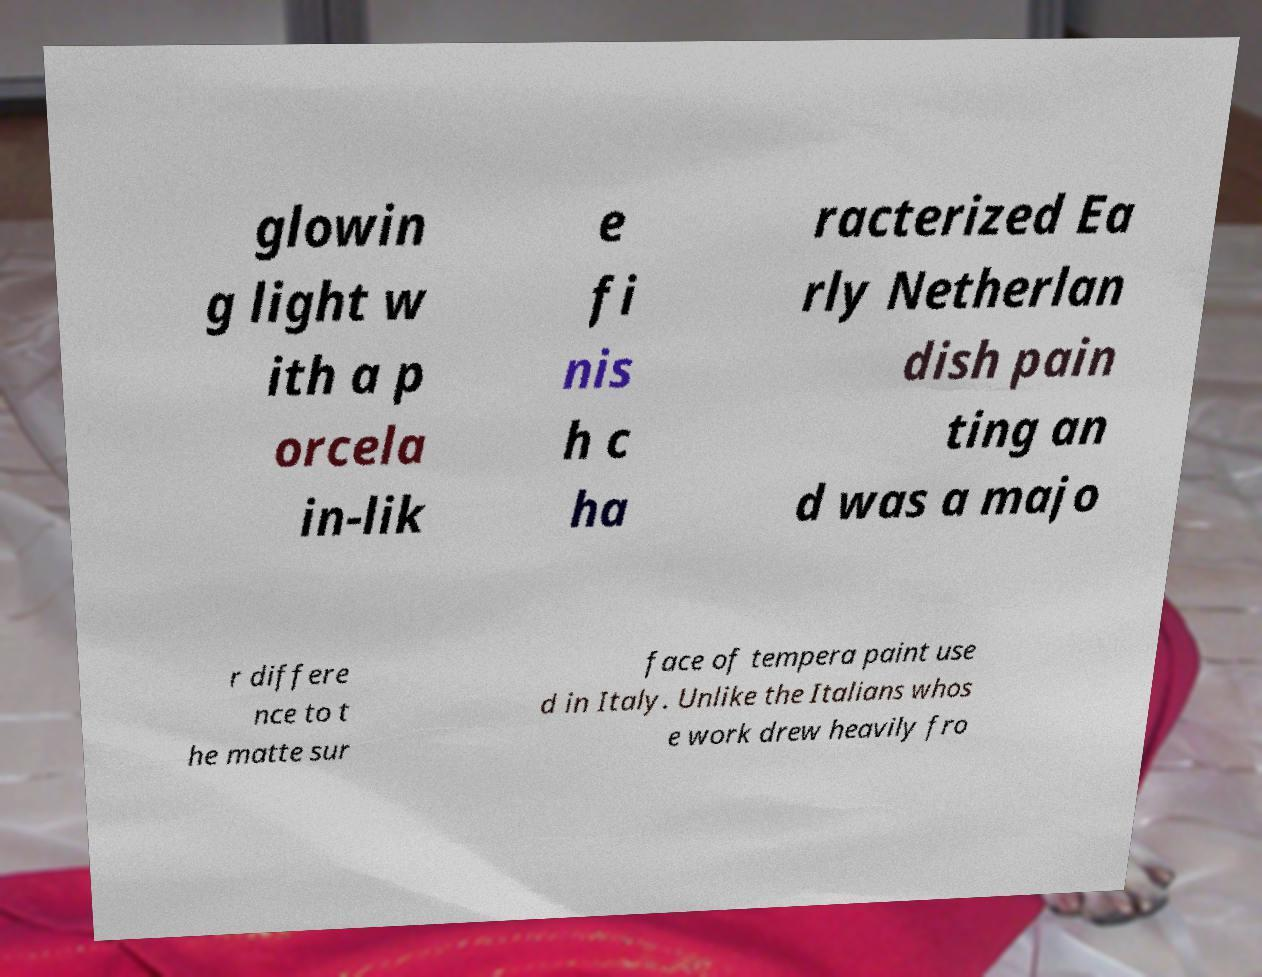What messages or text are displayed in this image? I need them in a readable, typed format. glowin g light w ith a p orcela in-lik e fi nis h c ha racterized Ea rly Netherlan dish pain ting an d was a majo r differe nce to t he matte sur face of tempera paint use d in Italy. Unlike the Italians whos e work drew heavily fro 